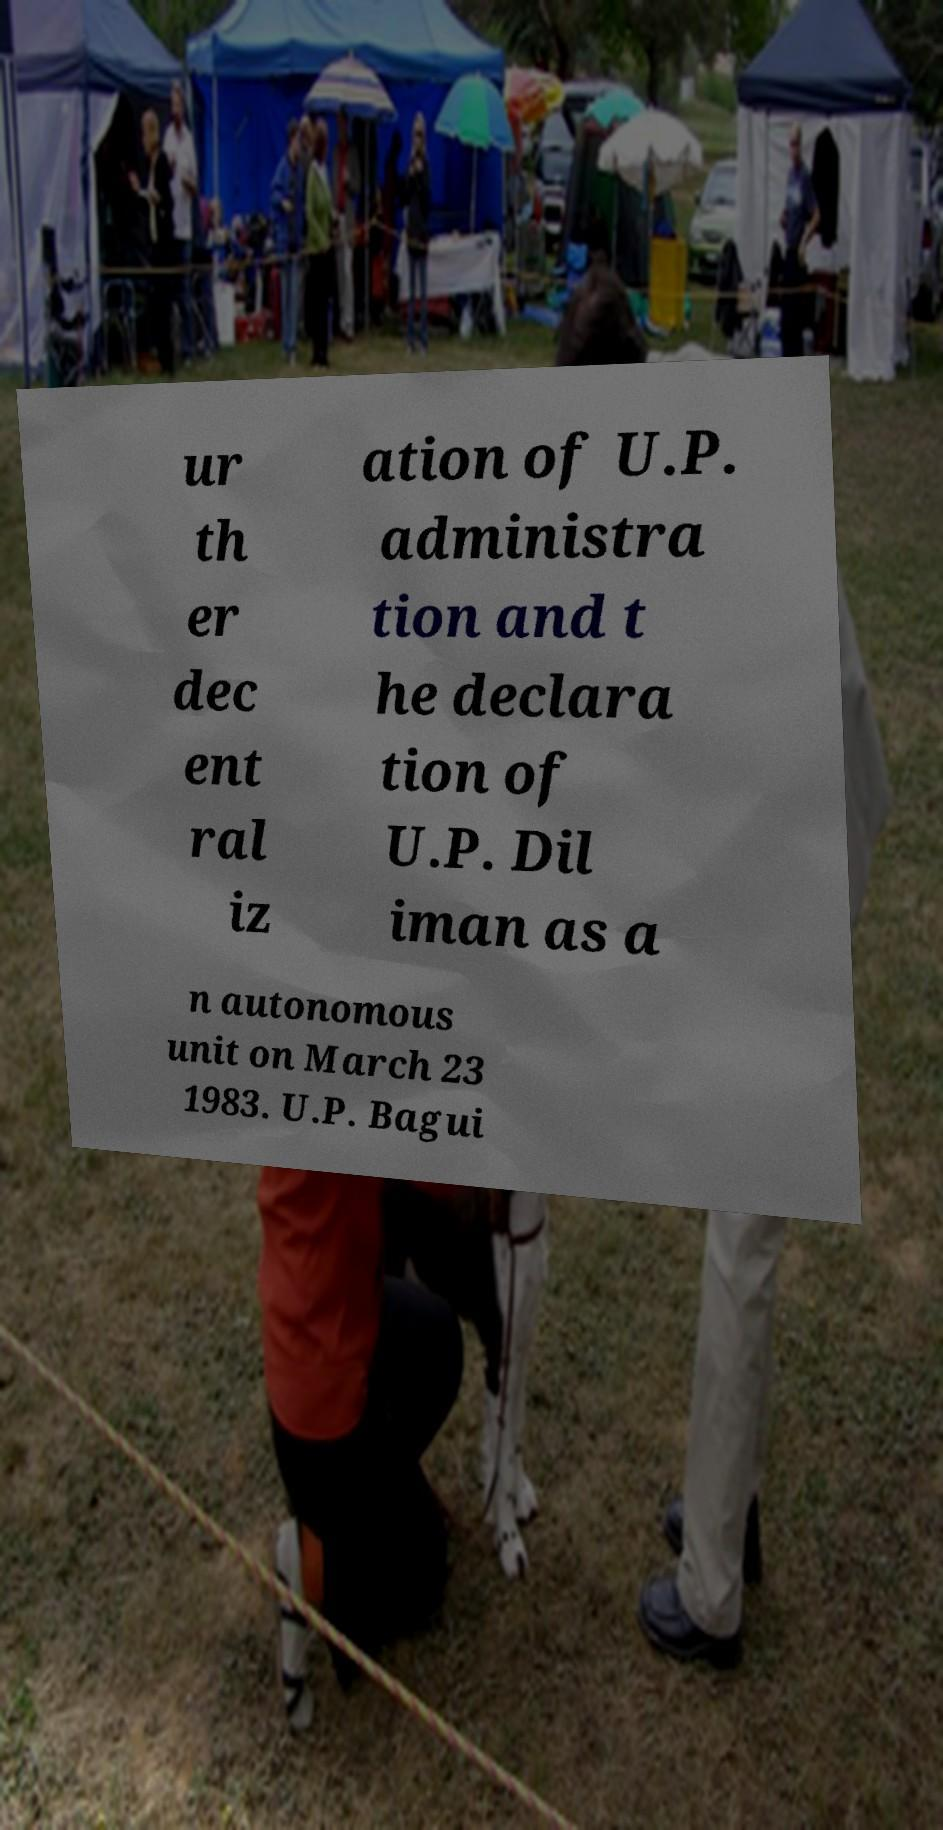Can you accurately transcribe the text from the provided image for me? ur th er dec ent ral iz ation of U.P. administra tion and t he declara tion of U.P. Dil iman as a n autonomous unit on March 23 1983. U.P. Bagui 